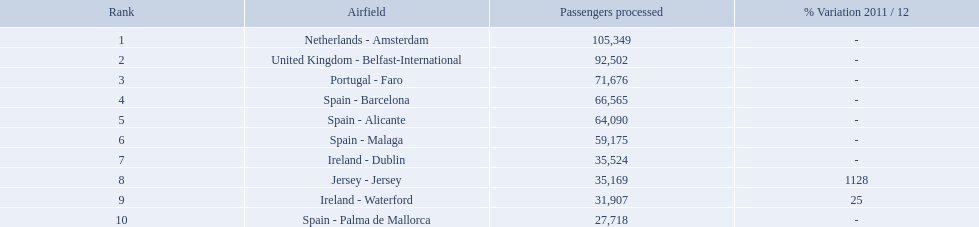Which airports had passengers going through london southend airport? Netherlands - Amsterdam, United Kingdom - Belfast-International, Portugal - Faro, Spain - Barcelona, Spain - Alicante, Spain - Malaga, Ireland - Dublin, Jersey - Jersey, Ireland - Waterford, Spain - Palma de Mallorca. Of those airports, which airport had the least amount of passengers going through london southend airport? Spain - Palma de Mallorca. What are all of the destinations out of the london southend airport? Netherlands - Amsterdam, United Kingdom - Belfast-International, Portugal - Faro, Spain - Barcelona, Spain - Alicante, Spain - Malaga, Ireland - Dublin, Jersey - Jersey, Ireland - Waterford, Spain - Palma de Mallorca. How many passengers has each destination handled? 105,349, 92,502, 71,676, 66,565, 64,090, 59,175, 35,524, 35,169, 31,907, 27,718. And of those, which airport handled the fewest passengers? Spain - Palma de Mallorca. What are all the passengers handled values for london southend airport? 105,349, 92,502, 71,676, 66,565, 64,090, 59,175, 35,524, 35,169, 31,907, 27,718. Which are 30,000 or less? 27,718. What airport is this for? Spain - Palma de Mallorca. What are the 10 busiest routes to and from london southend airport? Netherlands - Amsterdam, United Kingdom - Belfast-International, Portugal - Faro, Spain - Barcelona, Spain - Alicante, Spain - Malaga, Ireland - Dublin, Jersey - Jersey, Ireland - Waterford, Spain - Palma de Mallorca. Of these, which airport is in portugal? Portugal - Faro. What are all the airports in the top 10 busiest routes to and from london southend airport? Netherlands - Amsterdam, United Kingdom - Belfast-International, Portugal - Faro, Spain - Barcelona, Spain - Alicante, Spain - Malaga, Ireland - Dublin, Jersey - Jersey, Ireland - Waterford, Spain - Palma de Mallorca. Which airports are in portugal? Portugal - Faro. What is the highest number of passengers handled? 105,349. What is the destination of the passengers leaving the area that handles 105,349 travellers? Netherlands - Amsterdam. 